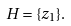Convert formula to latex. <formula><loc_0><loc_0><loc_500><loc_500>H = \{ z _ { 1 } \} .</formula> 